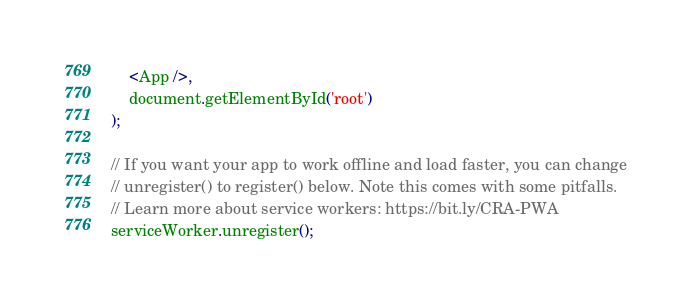Convert code to text. <code><loc_0><loc_0><loc_500><loc_500><_JavaScript_>	<App />,
	document.getElementById('root')
);

// If you want your app to work offline and load faster, you can change
// unregister() to register() below. Note this comes with some pitfalls.
// Learn more about service workers: https://bit.ly/CRA-PWA
serviceWorker.unregister();
</code> 